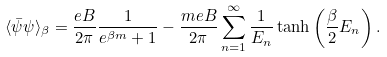Convert formula to latex. <formula><loc_0><loc_0><loc_500><loc_500>\langle \bar { \psi } \psi \rangle _ { \beta } = \frac { e B } { 2 \pi } \frac { 1 } { e ^ { \beta m } + 1 } - \frac { m e B } { 2 \pi } \sum _ { n = 1 } ^ { \infty } \frac { 1 } { E _ { n } } \tanh \left ( \frac { \beta } { 2 } E _ { n } \right ) .</formula> 